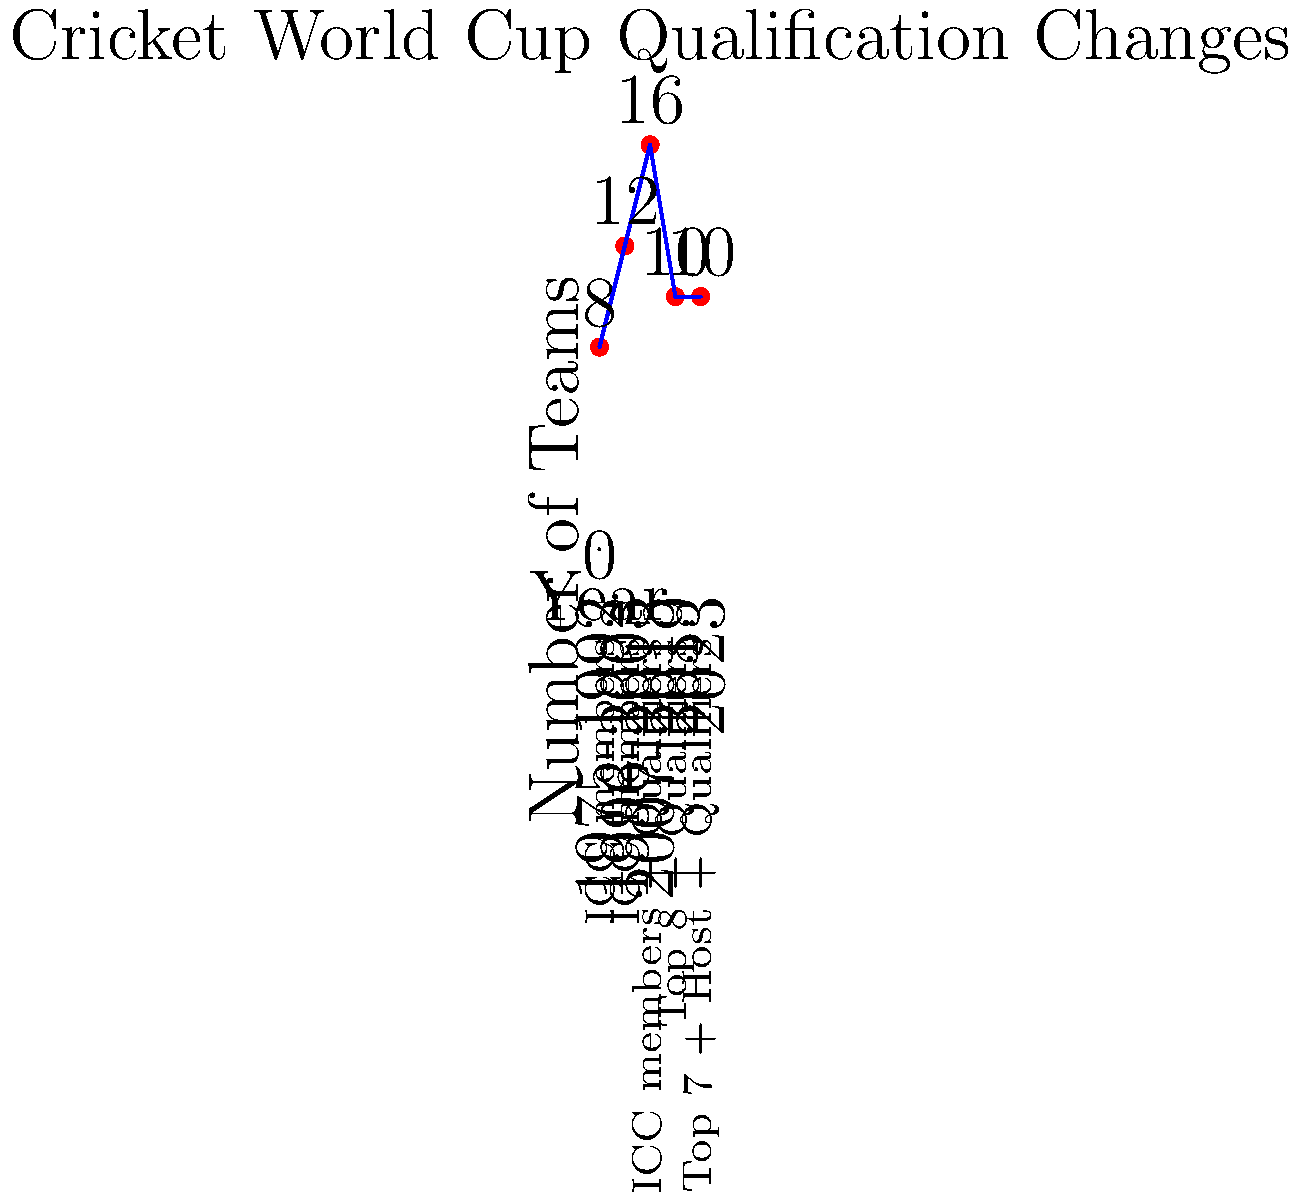Based on the infographic, which World Cup edition marked a significant shift in the qualification process, introducing a mix of top-ranked teams and qualifiers? To answer this question, let's analyze the infographic step-by-step:

1. The graph shows the evolution of the Cricket World Cup qualification process from 1975 to 2023.

2. We can see five distinct periods:
   - 1975-1992: 8 teams, all ICC members
   - 1996-2003: 12 teams, all ICC members
   - 2007-2015: 16 teams, ICC members + Qualifiers
   - 2019: 10 teams, Top 8 + Qualifiers
   - 2023: 10 teams, Top 7 + Host + Qualifiers

3. The key shift we're looking for is when the process changed from including all ICC members to a mix of top-ranked teams and qualifiers.

4. This change occurred in 2019, where the format changed to "Top 8 + Qualifiers".

5. This was a significant shift because it was the first time that not all Full Member nations were guaranteed a spot in the World Cup, with some having to go through a qualification process.

6. The 2023 edition slightly modified this approach, but still maintained the principle of including top-ranked teams and qualifiers.

Therefore, the 2019 World Cup marked the significant shift in the qualification process that the question is asking about.
Answer: 2019 World Cup 